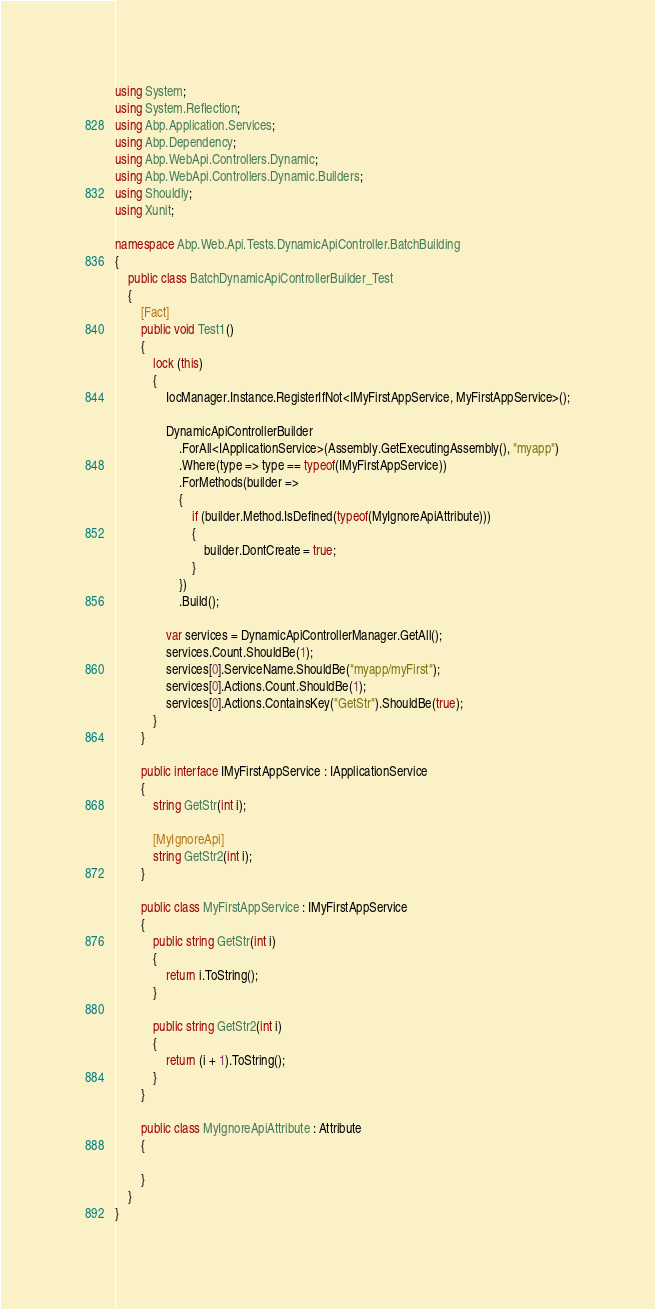<code> <loc_0><loc_0><loc_500><loc_500><_C#_>using System;
using System.Reflection;
using Abp.Application.Services;
using Abp.Dependency;
using Abp.WebApi.Controllers.Dynamic;
using Abp.WebApi.Controllers.Dynamic.Builders;
using Shouldly;
using Xunit;

namespace Abp.Web.Api.Tests.DynamicApiController.BatchBuilding
{
    public class BatchDynamicApiControllerBuilder_Test
    {
        [Fact]
        public void Test1()
        {
            lock (this)
            {
                IocManager.Instance.RegisterIfNot<IMyFirstAppService, MyFirstAppService>();

                DynamicApiControllerBuilder
                    .ForAll<IApplicationService>(Assembly.GetExecutingAssembly(), "myapp")
                    .Where(type => type == typeof(IMyFirstAppService))
                    .ForMethods(builder =>
                    {
                        if (builder.Method.IsDefined(typeof(MyIgnoreApiAttribute)))
                        {
                            builder.DontCreate = true;
                        }
                    })
                    .Build();

                var services = DynamicApiControllerManager.GetAll();
                services.Count.ShouldBe(1);
                services[0].ServiceName.ShouldBe("myapp/myFirst");
                services[0].Actions.Count.ShouldBe(1);
                services[0].Actions.ContainsKey("GetStr").ShouldBe(true);
            }
        }

        public interface IMyFirstAppService : IApplicationService
        {
            string GetStr(int i);

            [MyIgnoreApi]
            string GetStr2(int i);
        }

        public class MyFirstAppService : IMyFirstAppService
        {
            public string GetStr(int i)
            {
                return i.ToString();
            }

            public string GetStr2(int i)
            {
                return (i + 1).ToString();
            }
        }

        public class MyIgnoreApiAttribute : Attribute
        {

        }
    }
}</code> 